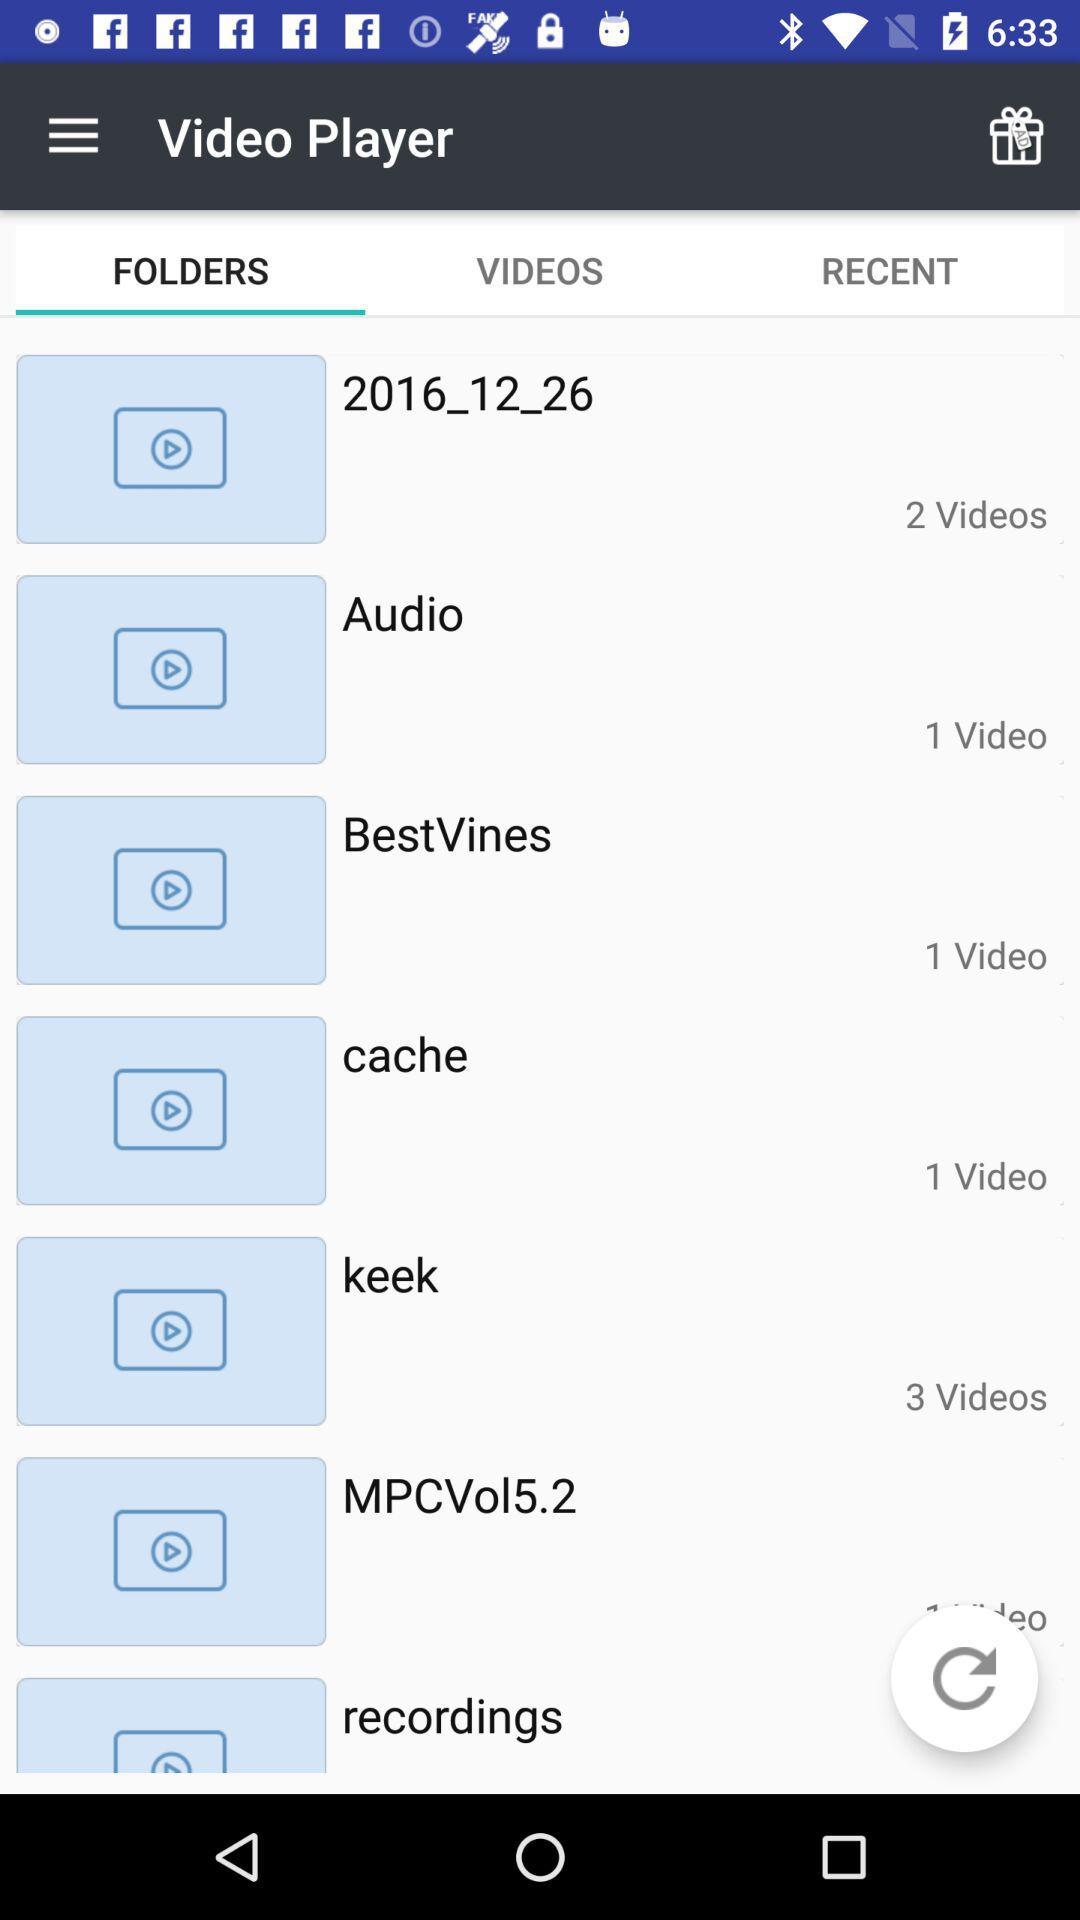How many videos are in the 'BestVines' folder?
Answer the question using a single word or phrase. 1 